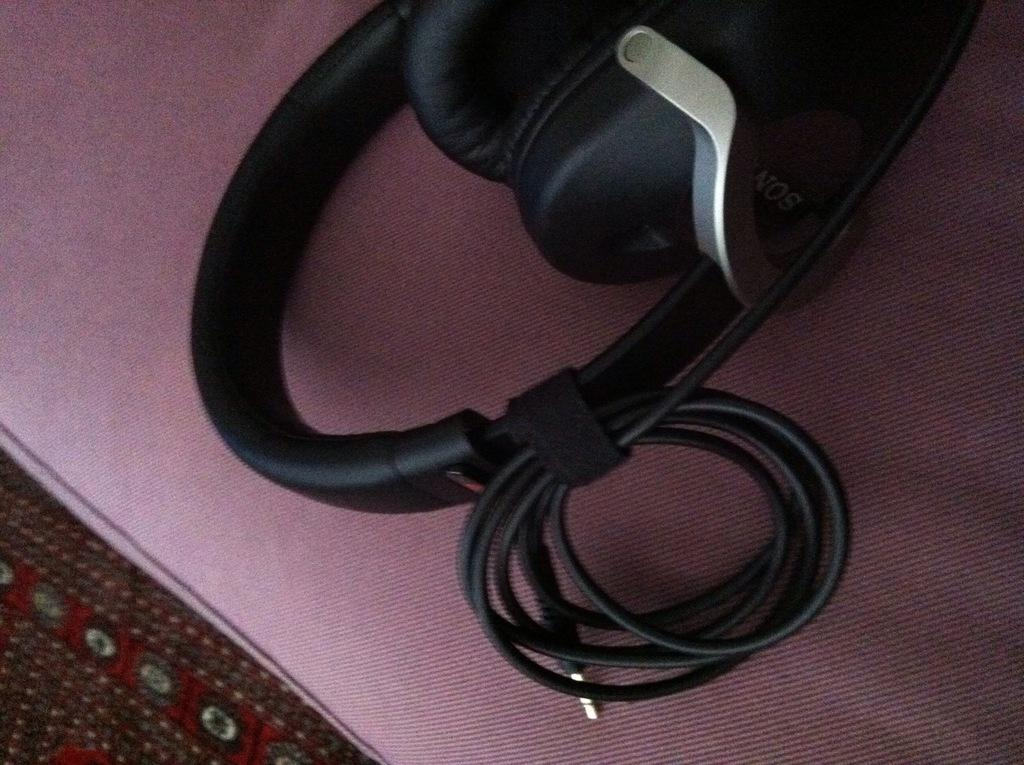What type of device is visible in the image? There is a headset in the image. What is the color of the headset? The headset is black in color. Can you see any veins in the headset? There are no veins present in the headset, as it is an electronic device and not a living organism. 